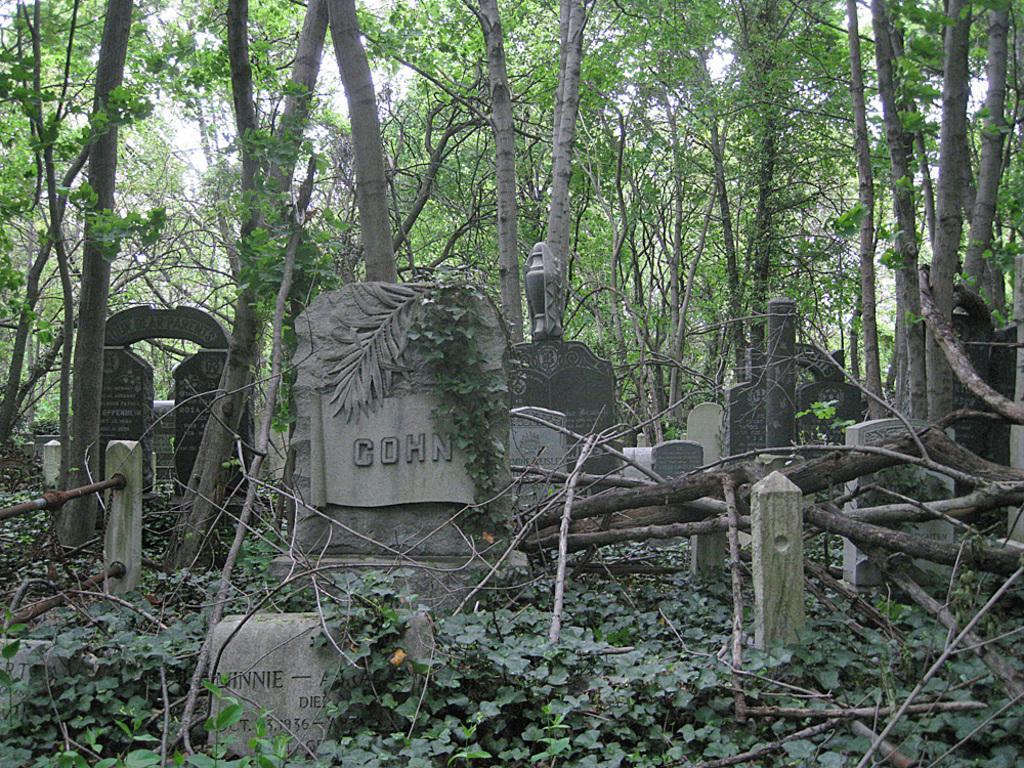Please provide a concise description of this image. In this picture I can see there is a grave yard with few grave stones and there are tree trunks here and in the backdrop there are few trees and the sky is clear. 